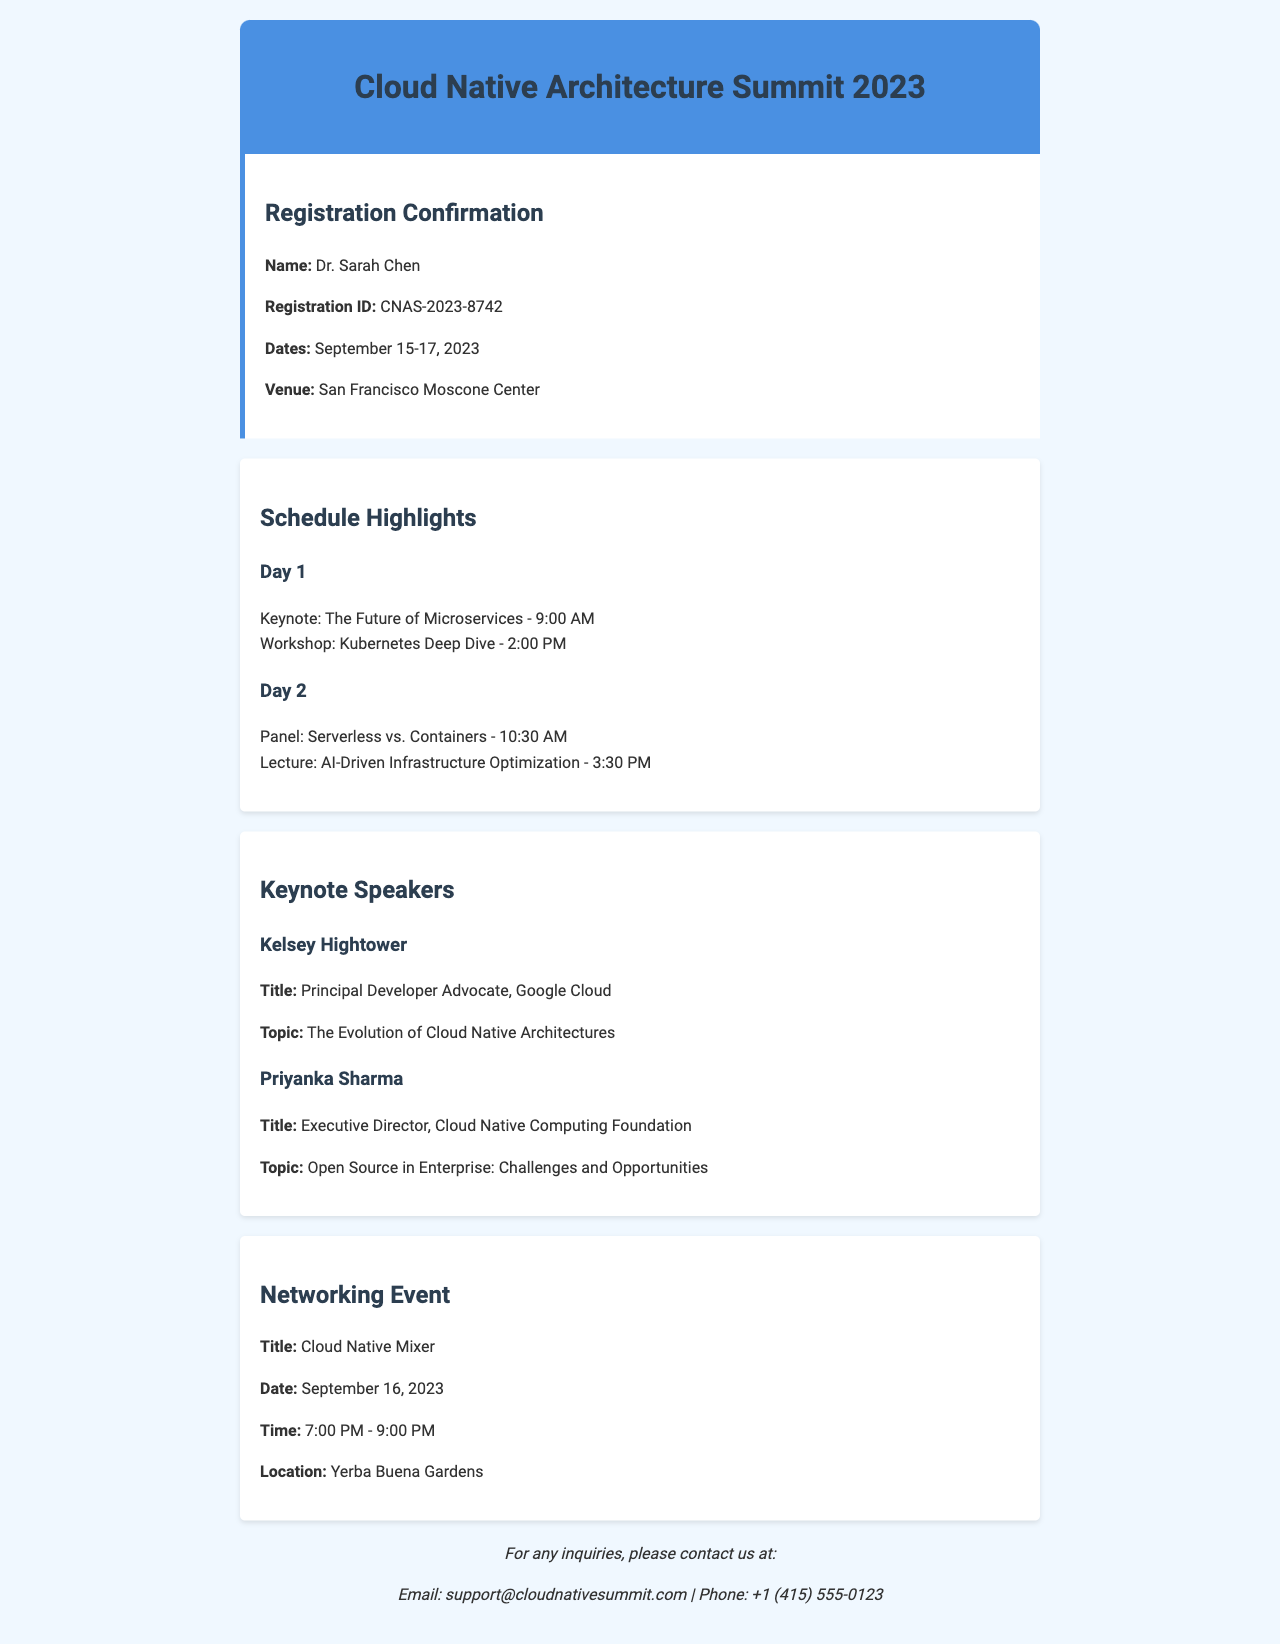What is the name of the attendee? The attendee's name is mentioned in the registration confirmation section of the document.
Answer: Dr. Sarah Chen What is the registration ID? The registration ID is provided in the confirmation details.
Answer: CNAS-2023-8742 What is the venue for the summit? The venue details are included under registration confirmation.
Answer: San Francisco Moscone Center What is the date and time of the keynote session? The date and time can be found in the schedule section under Day 1.
Answer: September 15, 9:00 AM Who is the keynote speaker? The keynote speaker's name is listed in the keynote speakers section.
Answer: Kelsey Hightower What is the title of Priyanka Sharma's talk? The specific topic title is mentioned alongside the speaker's name.
Answer: Open Source in Enterprise: Challenges and Opportunities When is the Cloud Native Mixer event scheduled? The date and time for this networking event are noted in the networking section.
Answer: September 16, 7:00 PM - 9:00 PM How many days does the summit last? The duration of the event can be calculated from the confirmation details.
Answer: Three days What is the theme of Day 2's panel discussion? The theme is highlighted in the schedule section under Day 2.
Answer: Serverless vs. Containers 